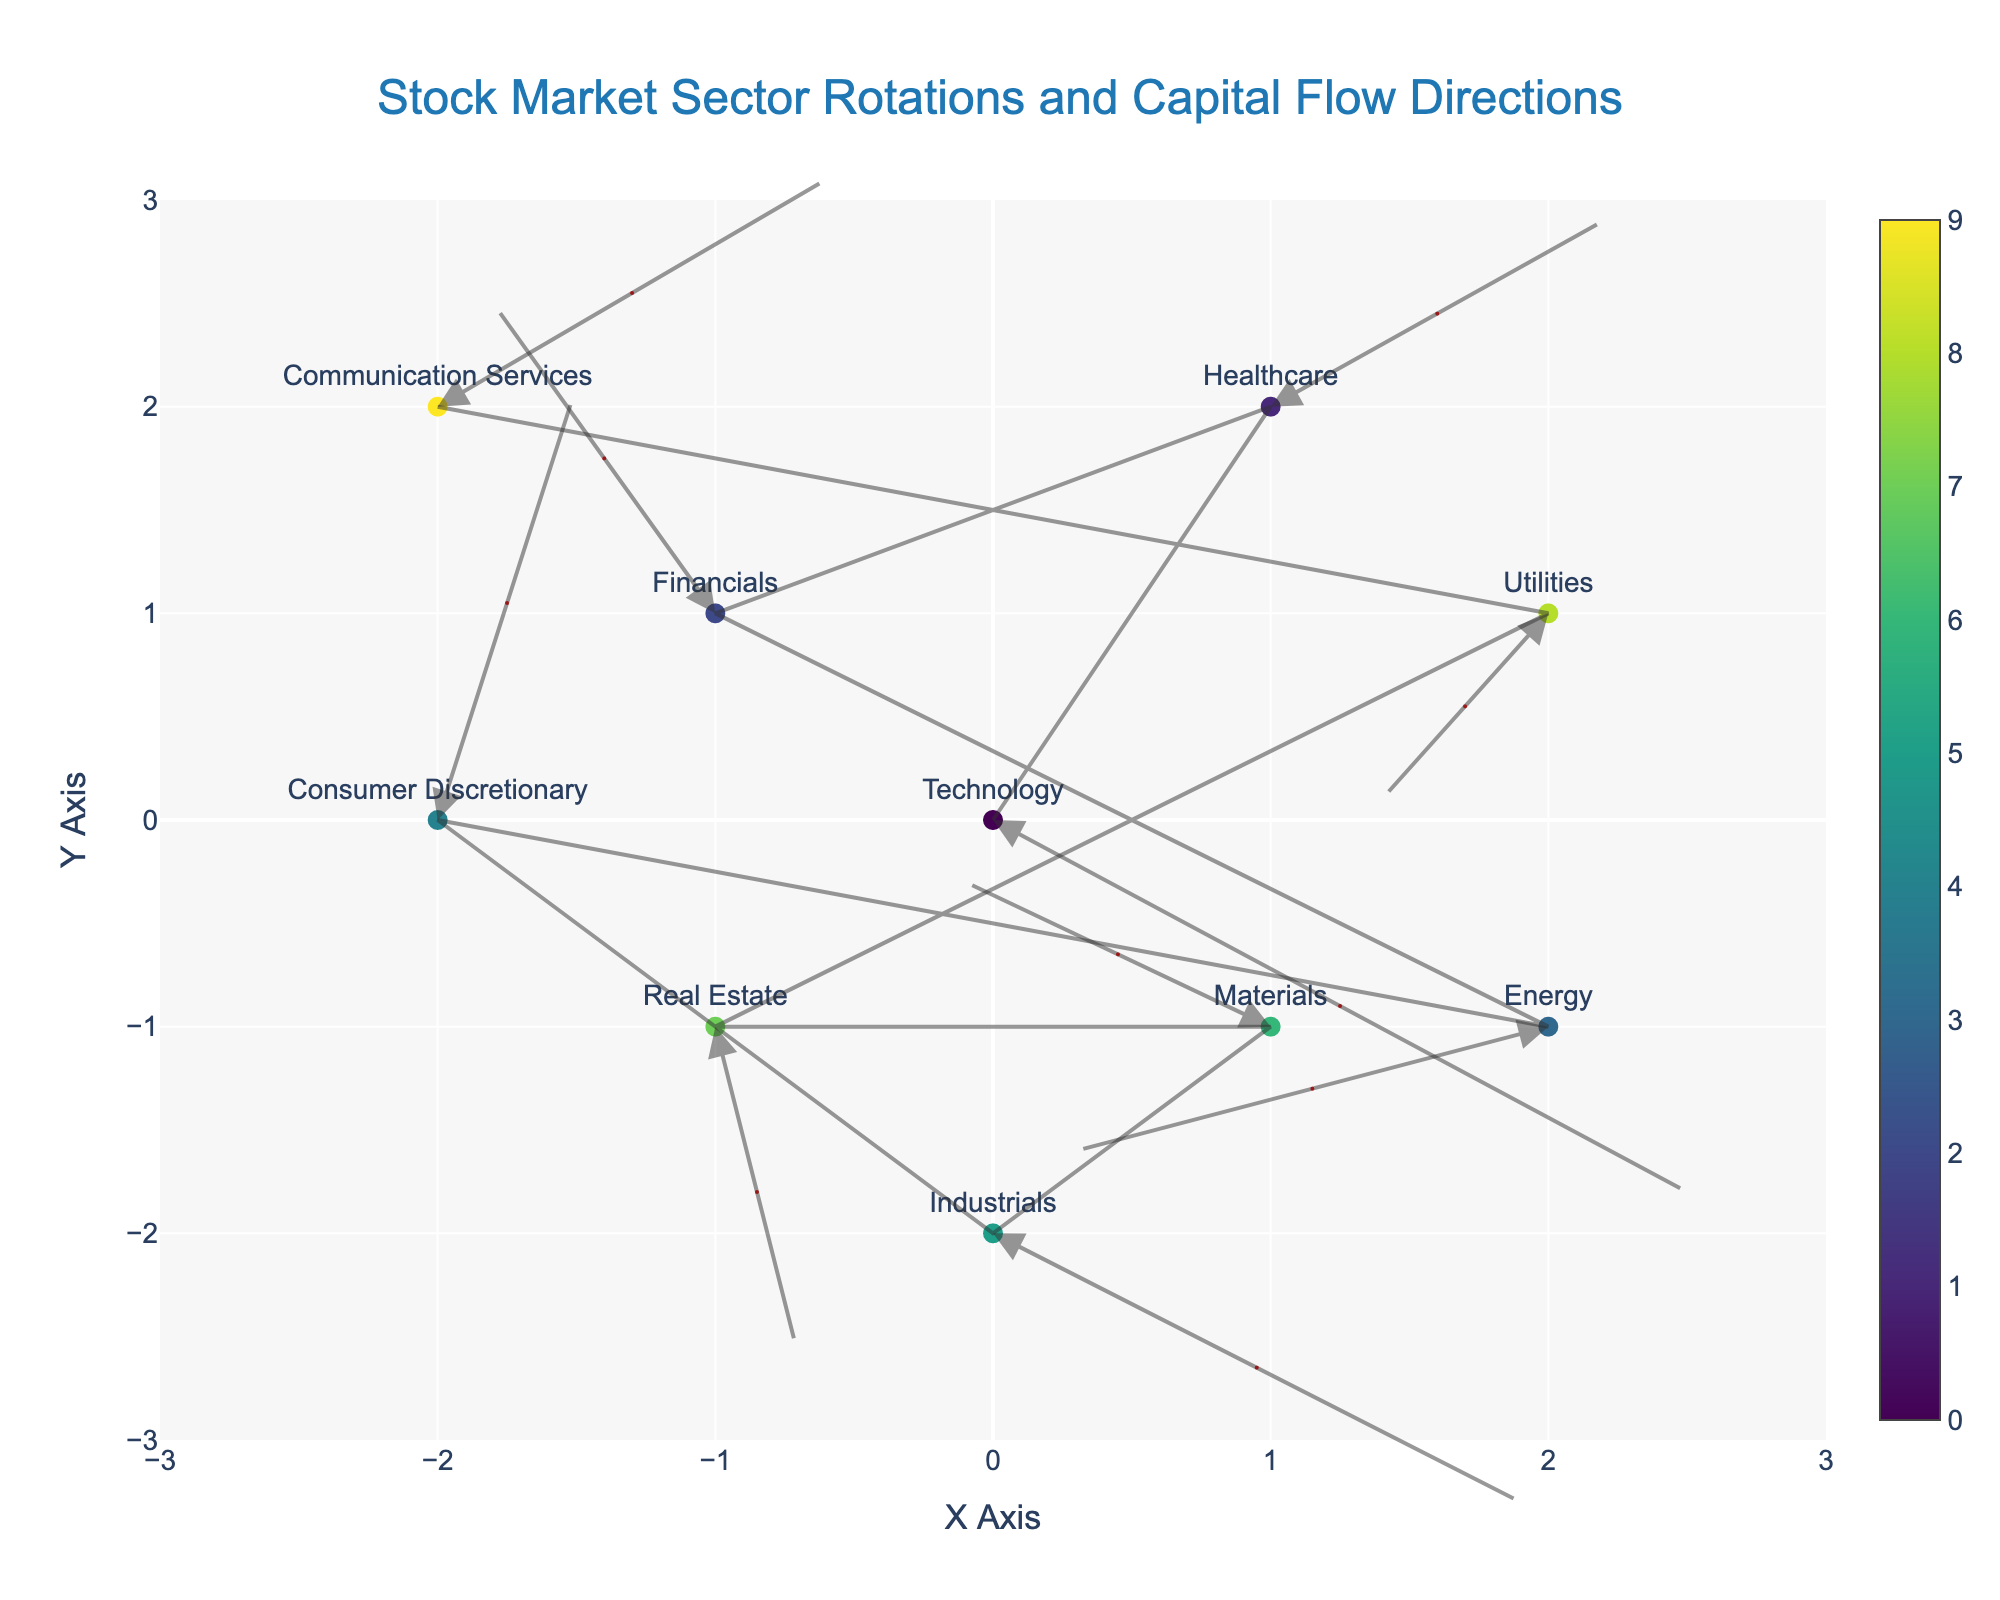What is the title of the plot? The title is prominently displayed at the top-center of the plot. In this case, it reads "Stock Market Sector Rotations and Capital Flow Directions".
Answer: Stock Market Sector Rotations and Capital Flow Directions Which sector is associated with the economic indicator "Interest Rates"? The hover text or labels on the plot indicate the economic indicator associated with each sector. By looking closely, we see "Financials" linked to "Interest Rates".
Answer: Financials Which sector experiences the largest shift to the right on the X-axis? The horizontal (X-axis) shift can be observed through the length of the arrows. "Technology" has the largest shift as its U-component is 2.5, the highest among all sectors.
Answer: Technology Which sectors show a negative change in their Y-direction? The Y-direction is represented by the V-component of the arrows. Sectors with negative values in the Y-direction include Technology, Energy, Industrials, and Real Estate.
Answer: Technology, Energy, Industrials, Real Estate How many sectors have a positive change in both X and Y directions? Both X and Y directions being positive means both U and V are positive. The sectors that fulfill this criterion are Healthcare and Communication Services.
Answer: Two sectors Which sector shows the highest upward (positive Y) movement and what is its economic indicator? By observing the values of V, Consumer Discretionary has the highest upward movement with a V-value of 2.1. The economic indicator is "Consumer Confidence".
Answer: Consumer Discretionary, Consumer Confidence Compare the movement of Financials and Technology sectors. Which one has a greater net change in position? Net change can be calculated using the Pythagorean theorem: sqrt(U^2 + V^2). For Technology: sqrt(2.5^2 + (-1.8)^2) ~ 3.05. For Financials: sqrt((-0.8)^2 + 1.5^2) ~ 1.71. Technology has a greater net change.
Answer: Technology Which sector has the most substantial negative horizontal shift, and what is the value of that shift? Negative horizontal shift is indicated by the negative value of the U-component. Energy has the most substantial negative horizontal shift with U = -1.7.
Answer: Energy, -1.7 